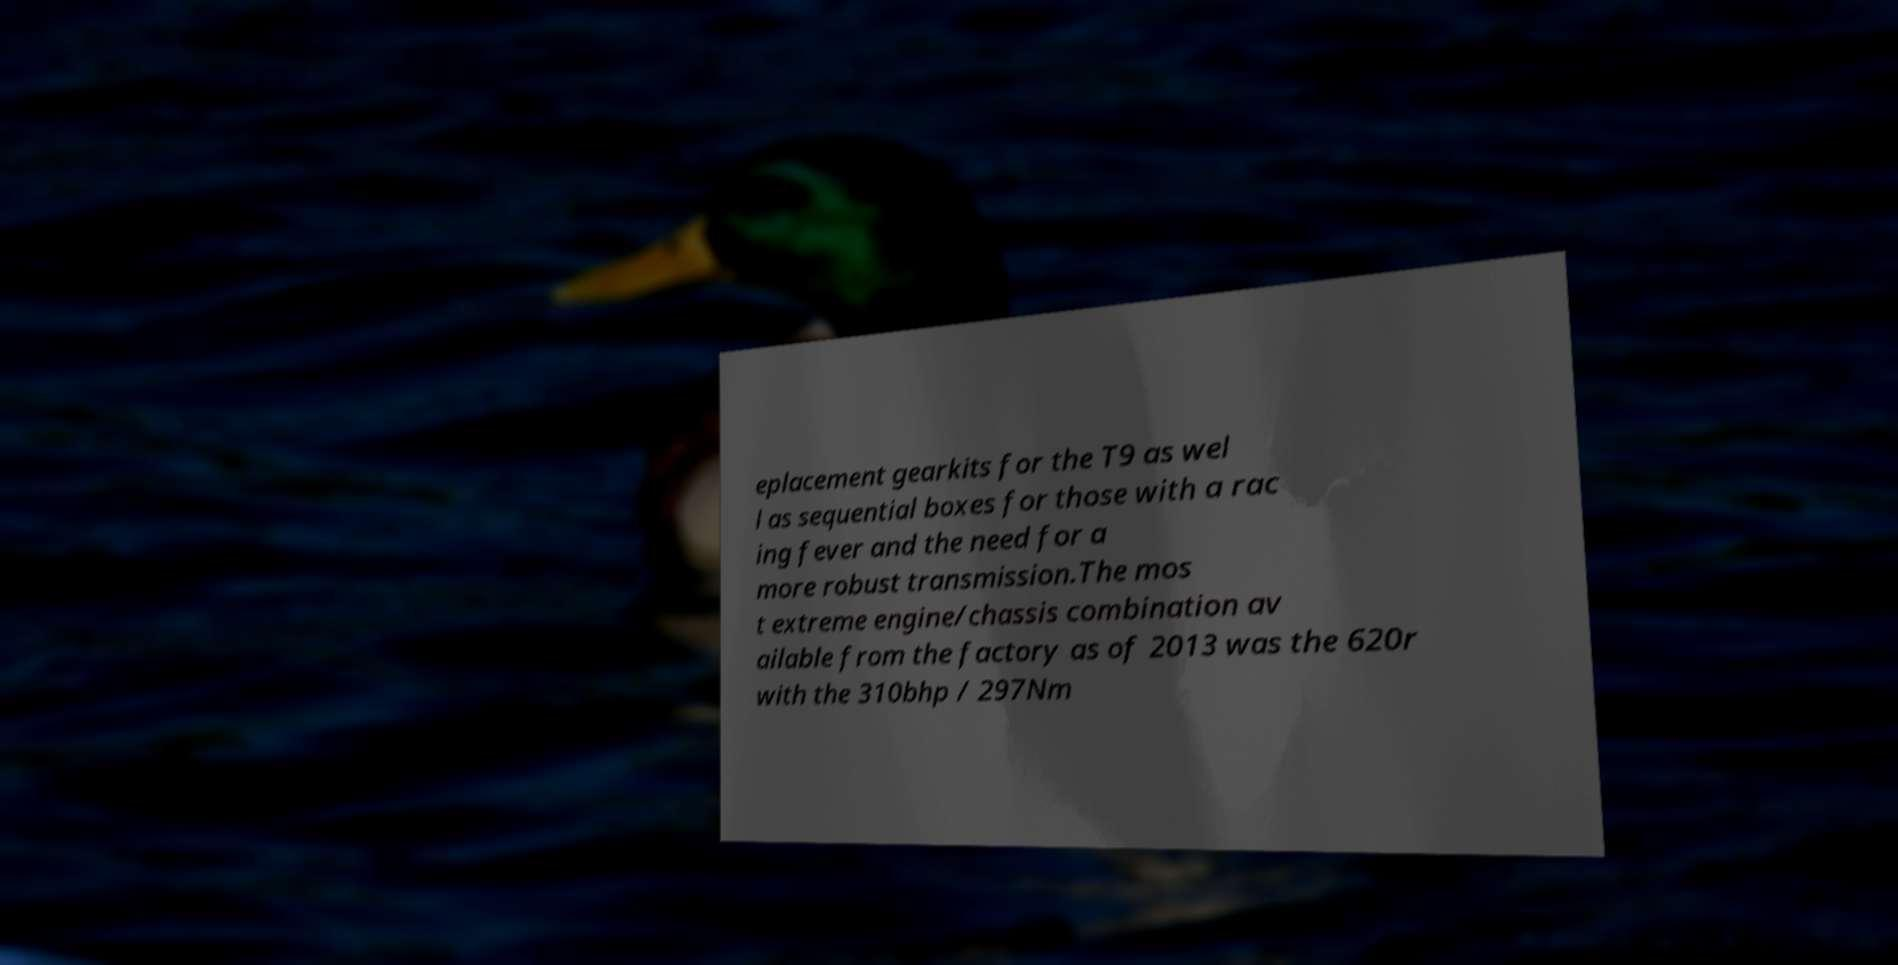Can you read and provide the text displayed in the image?This photo seems to have some interesting text. Can you extract and type it out for me? eplacement gearkits for the T9 as wel l as sequential boxes for those with a rac ing fever and the need for a more robust transmission.The mos t extreme engine/chassis combination av ailable from the factory as of 2013 was the 620r with the 310bhp / 297Nm 